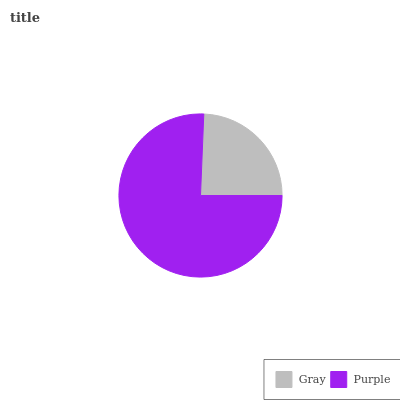Is Gray the minimum?
Answer yes or no. Yes. Is Purple the maximum?
Answer yes or no. Yes. Is Purple the minimum?
Answer yes or no. No. Is Purple greater than Gray?
Answer yes or no. Yes. Is Gray less than Purple?
Answer yes or no. Yes. Is Gray greater than Purple?
Answer yes or no. No. Is Purple less than Gray?
Answer yes or no. No. Is Purple the high median?
Answer yes or no. Yes. Is Gray the low median?
Answer yes or no. Yes. Is Gray the high median?
Answer yes or no. No. Is Purple the low median?
Answer yes or no. No. 